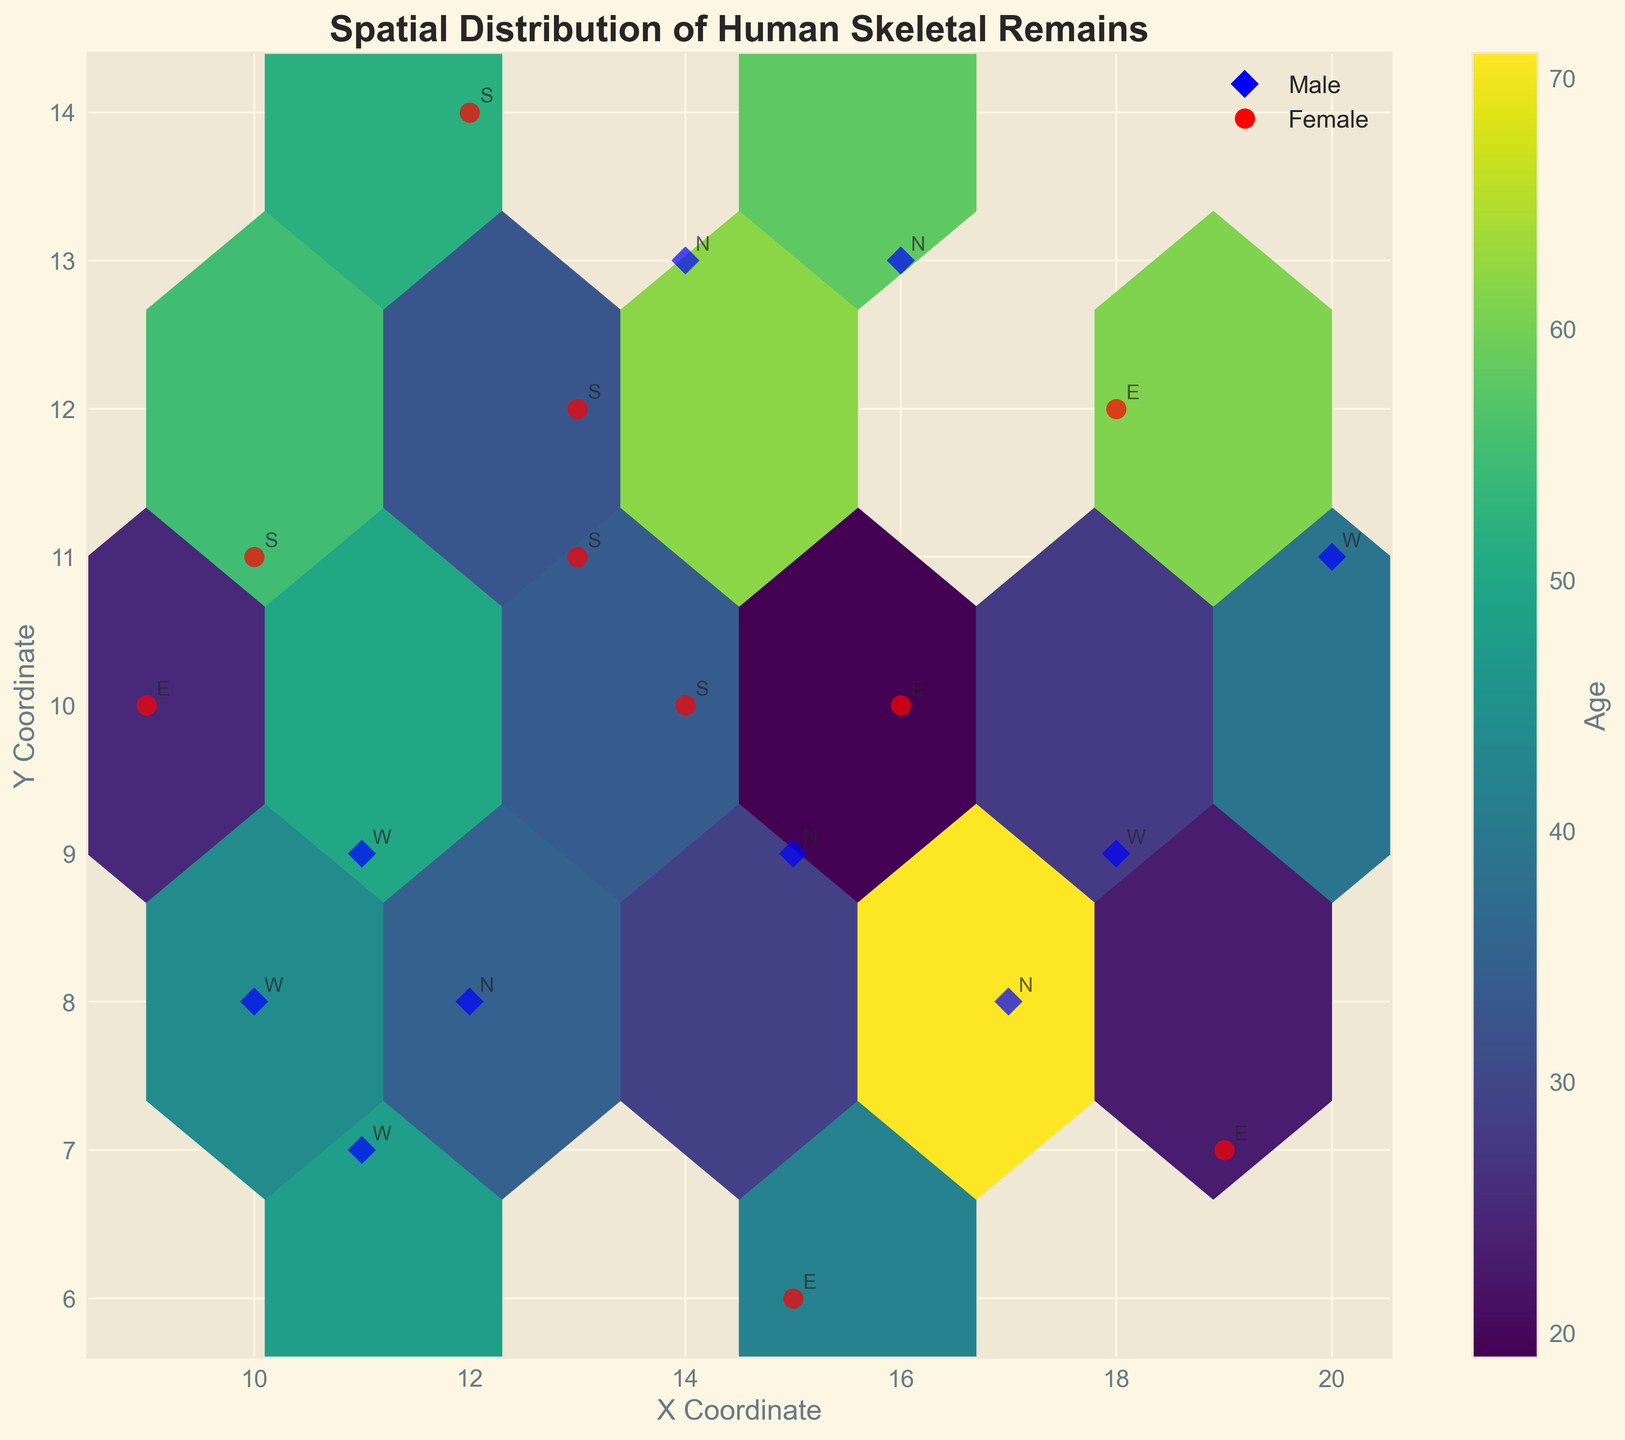Where is the highest density of skeletal remains located? The hexbin plot shows darker regions where the density is higher. The highest density is visible in the region where x is around 14 and y is around 10.
Answer: Around (14, 10) What is the title of the figure? The title is located at the top of the figure and is typically in bold text. The title is "Spatial Distribution of Human Skeletal Remains."
Answer: Spatial Distribution of Human Skeletal Remains What color represents older individuals in the figure? The color bar on the right side of the plot indicates age distribution. Older individuals are represented by colors toward the upper end of the color spectrum, which is a lighter green-yellow.
Answer: Lighter green-yellow What is the age range of individuals buried at coordinates (16, 10)? By observing the color bar and comparing the color at coordinates (16,10), it corresponds to a specific age range. The color at this coordinate is a darker green, correlating to the lower end of the age spectrum displayed on the color bar.
Answer: Around 19 years How many males are annotated with the 'N' orientation? The plot uses blue diamond markers to represent males. By counting these markers annotated with 'N', they are found at (12,8), (14,13), (17,8), and (15,9). Hence, there are 4 such males.
Answer: 4 Which gender is represented more frequently in the northeastern section of the plot? The northeastern section is the top-right part of the plot. By counting the markers (blue for males and red for females) in this section, it appears there are more red circles than blue diamonds.
Answer: Females At what coordinates is the oldest individual found? The color bar shows age, and the lightest color represents the oldest individuals. Checking the plot, the lightest color (offspring of yellow and green mix) appears at (17, 8), age 71.
Answer: (17, 8) Which burial orientation is found most frequently in the plot? By noting the annotation letters (N, E, W, S) across the plot, one can count the frequency of each. 'N' appears most frequently.
Answer: N Which area of the plot shows the greatest diversity in age? The greatest diversity in age would be reflected in a mix of different colors within a small region of the plot. The middle region around coordinates (14,10) shows a variety of colors, indicating a diverse age range.
Answer: Middle region around (14,10) What is the average age of the individuals oriented towards the south (S)? From the plot, the individuals marked with 'S' are at coordinates (10,11), age 55; (13,12), age 33; (12,14), age 52; and (14,10), age 31. The average is calculated as follows: (55 + 33 + 52 + 31) / 4 = 42.75.
Answer: 42.75 